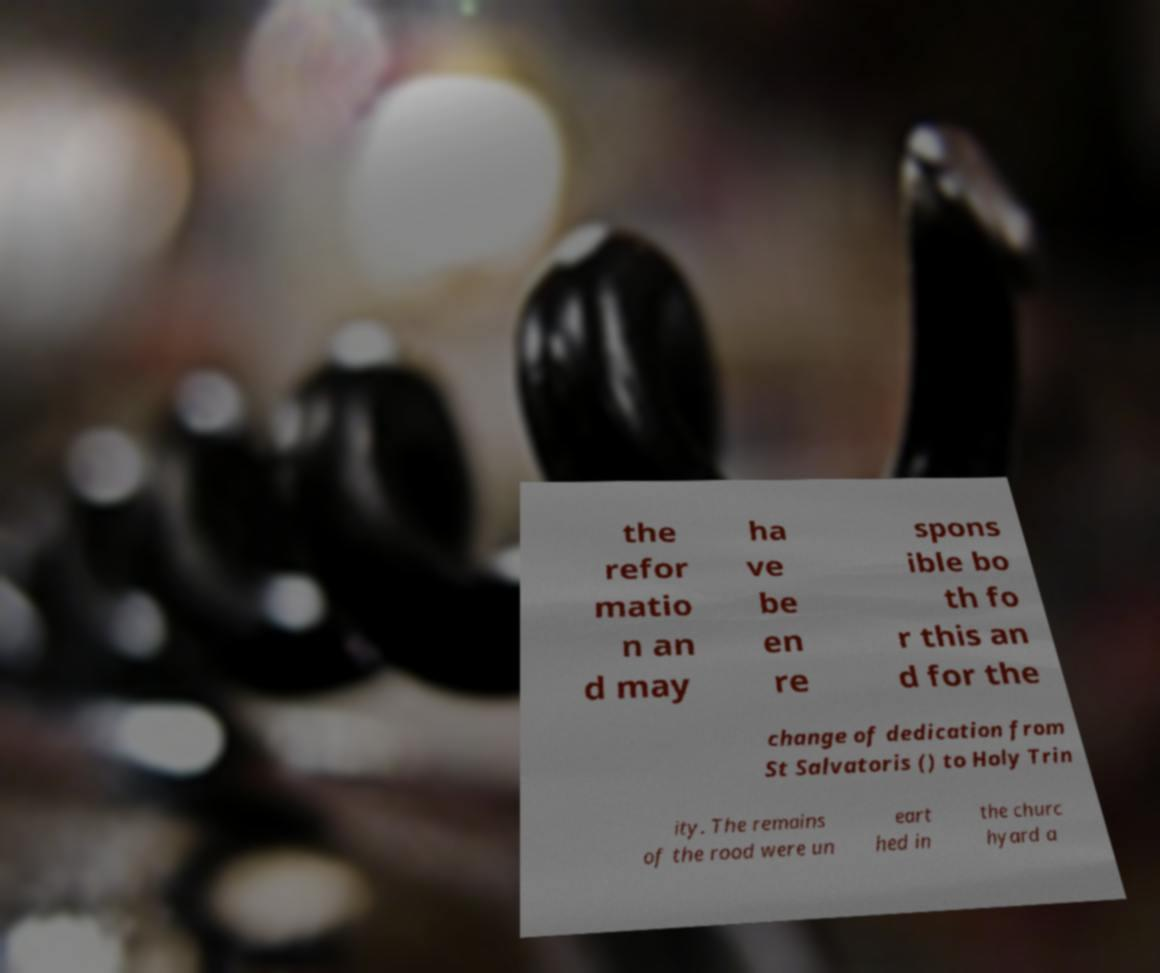Could you extract and type out the text from this image? the refor matio n an d may ha ve be en re spons ible bo th fo r this an d for the change of dedication from St Salvatoris () to Holy Trin ity. The remains of the rood were un eart hed in the churc hyard a 